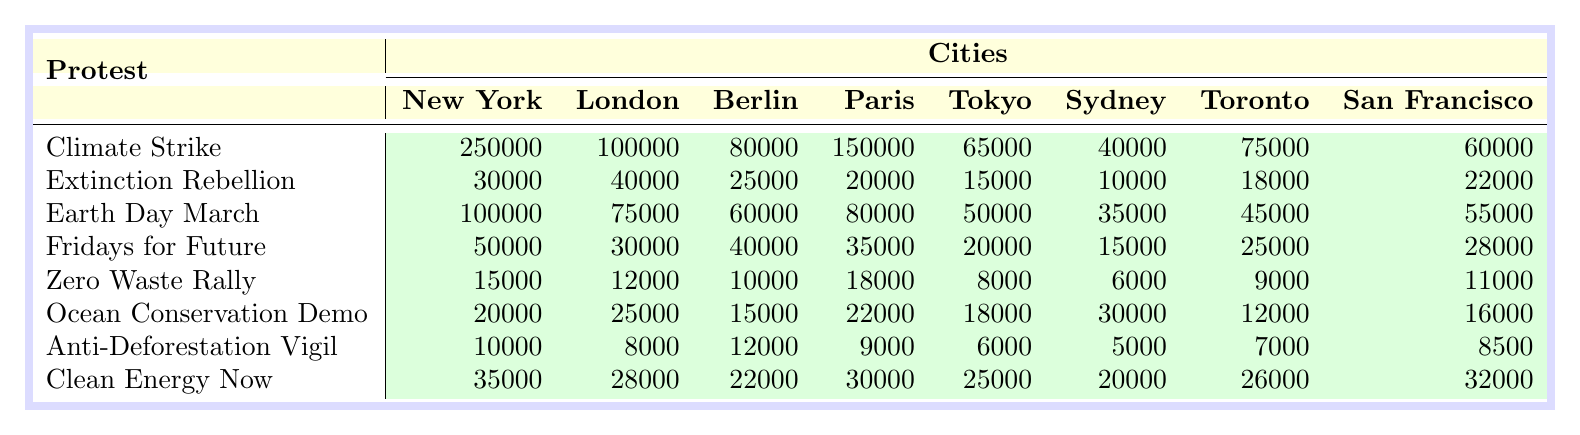What city had the highest attendance for the Climate Strike? Looking at the table, the attendance for the Climate Strike is highest in New York with 250,000 participants compared to other cities.
Answer: New York Which protest had the lowest attendance overall? By scanning through the attendance numbers for each protest, the Anti-Deforestation Vigil had the lowest attendance of 10,000 across all cities.
Answer: Anti-Deforestation Vigil What is the total attendance for Earth Day March across all cities? The attendance for the Earth Day March in each city is: New York (100,000), London (75,000), Berlin (60,000), Paris (80,000), Tokyo (50,000), Sydney (35,000), Toronto (45,000), and San Francisco (55,000). Summing these gives: 100,000 + 75,000 + 60,000 + 80,000 + 50,000 + 35,000 + 45,000 + 55,000 = 450,000.
Answer: 450,000 Which protest in Tokyo had attendance greater than 10,000? Checking the Tokyo attendance numbers, only the Climate Strike (65,000), Earth Day March (50,000), Fridays for Future (20,000), Ocean Conservation Demo (18,000), and Clean Energy Now (25,000) had attendance greater than 10,000.
Answer: Climate Strike, Earth Day March, Fridays for Future, Ocean Conservation Demo, Clean Energy Now What was the average attendance for protests held in London? The attendance in London for each protest is: 100,000 (Climate Strike), 40,000 (Extinction Rebellion), 75,000 (Earth Day March), 30,000 (Fridays for Future), 12,000 (Zero Waste Rally), 25,000 (Ocean Conservation Demo), 8,000 (Anti-Deforestation Vigil), and 28,000 (Clean Energy Now). Summing these gives 100,000 + 40,000 + 75,000 + 30,000 + 12,000 + 25,000 + 8,000 + 28,000 = 318,000. Dividing by 8 (the number of protests) gives an average of 39,750.
Answer: 39,750 Did any protest in San Francisco reach an attendance of 30,000 or more? Looking at the attendance numbers for San Francisco, the only protest that reached 30,000 was the Clean Energy Now, which had 30,000 participants.
Answer: Yes 